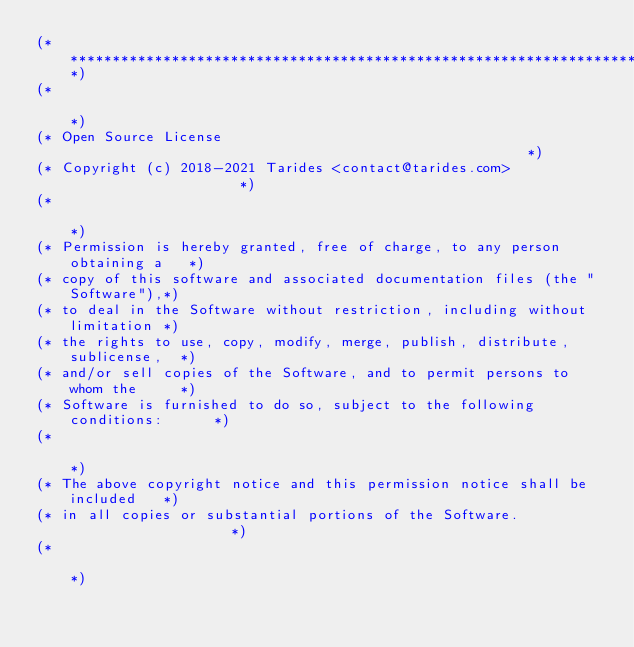<code> <loc_0><loc_0><loc_500><loc_500><_OCaml_>(*****************************************************************************)
(*                                                                           *)
(* Open Source License                                                       *)
(* Copyright (c) 2018-2021 Tarides <contact@tarides.com>                     *)
(*                                                                           *)
(* Permission is hereby granted, free of charge, to any person obtaining a   *)
(* copy of this software and associated documentation files (the "Software"),*)
(* to deal in the Software without restriction, including without limitation *)
(* the rights to use, copy, modify, merge, publish, distribute, sublicense,  *)
(* and/or sell copies of the Software, and to permit persons to whom the     *)
(* Software is furnished to do so, subject to the following conditions:      *)
(*                                                                           *)
(* The above copyright notice and this permission notice shall be included   *)
(* in all copies or substantial portions of the Software.                    *)
(*                                                                           *)</code> 